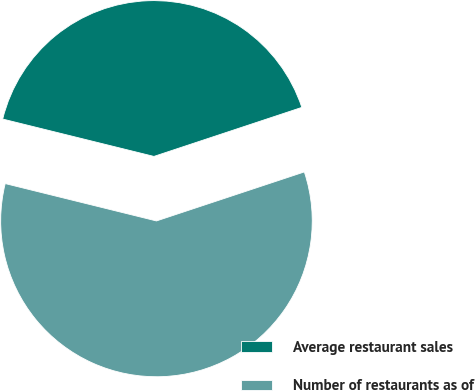Convert chart to OTSL. <chart><loc_0><loc_0><loc_500><loc_500><pie_chart><fcel>Average restaurant sales<fcel>Number of restaurants as of<nl><fcel>41.05%<fcel>58.95%<nl></chart> 